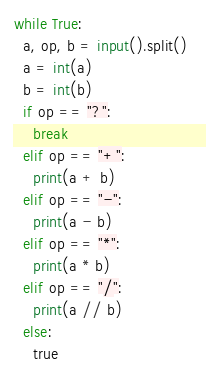Convert code to text. <code><loc_0><loc_0><loc_500><loc_500><_Python_>while True:  
  a, op, b = input().split() 
  a = int(a)                   
  b = int(b)
  if op == "?":
    break
  elif op == "+":
    print(a + b)
  elif op == "-":
    print(a - b)
  elif op == "*":
    print(a * b)
  elif op == "/":
    print(a // b)
  else:
    true
</code> 